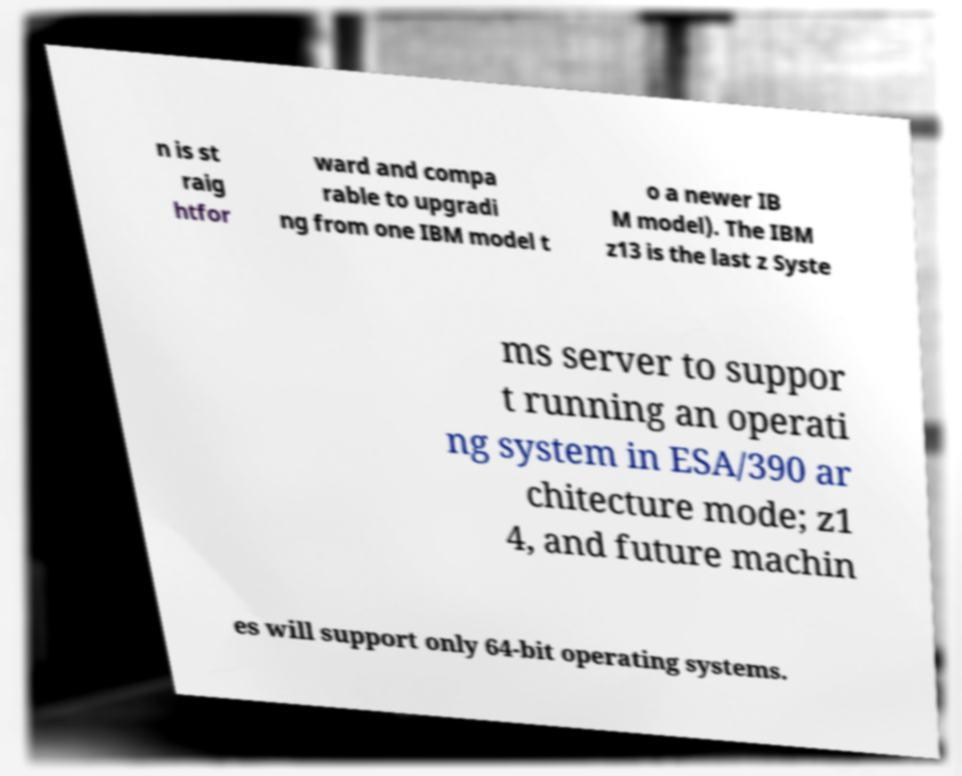Could you extract and type out the text from this image? n is st raig htfor ward and compa rable to upgradi ng from one IBM model t o a newer IB M model). The IBM z13 is the last z Syste ms server to suppor t running an operati ng system in ESA/390 ar chitecture mode; z1 4, and future machin es will support only 64-bit operating systems. 